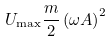<formula> <loc_0><loc_0><loc_500><loc_500>U _ { \max } { \frac { m } { 2 } } \left ( \omega A \right ) ^ { 2 }</formula> 